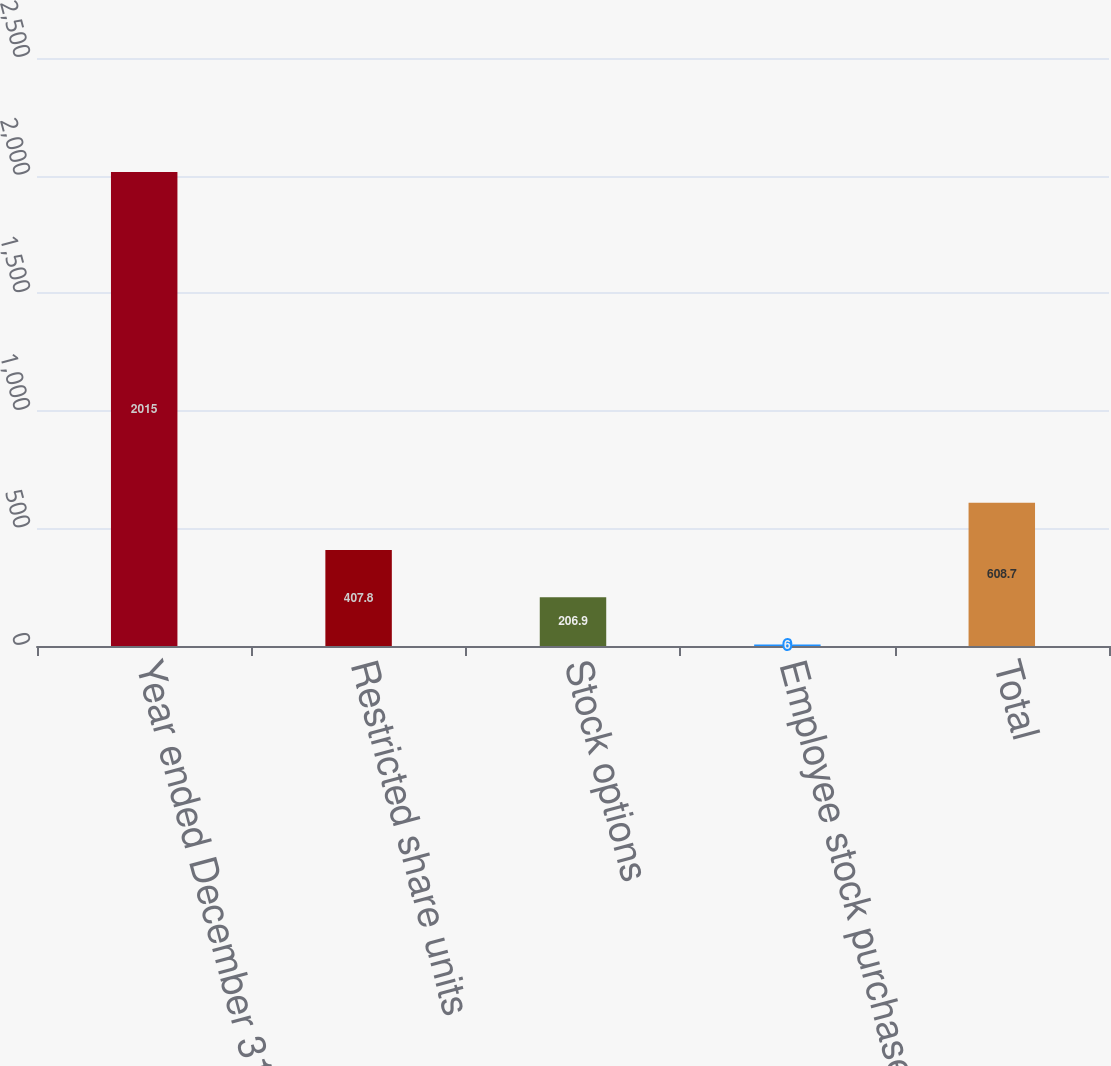<chart> <loc_0><loc_0><loc_500><loc_500><bar_chart><fcel>Year ended December 31 (in<fcel>Restricted share units<fcel>Stock options<fcel>Employee stock purchase plans<fcel>Total<nl><fcel>2015<fcel>407.8<fcel>206.9<fcel>6<fcel>608.7<nl></chart> 